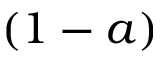<formula> <loc_0><loc_0><loc_500><loc_500>( 1 - a )</formula> 